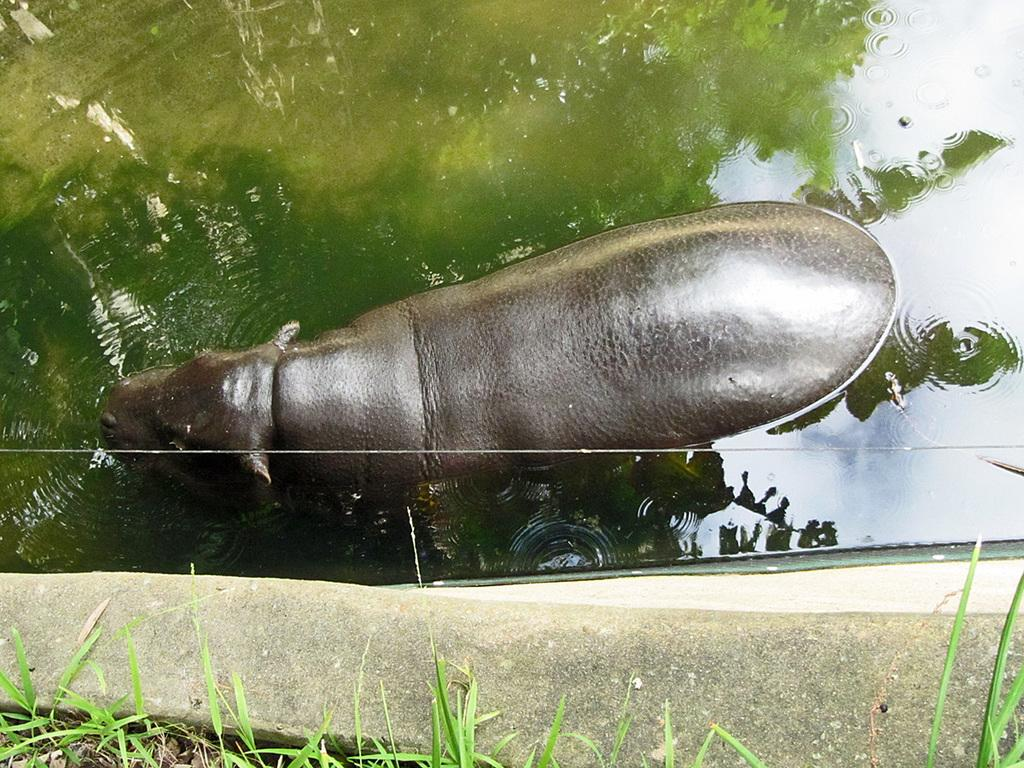What type of animal can be seen in the image? There is an animal in a pond in the image. What is located at the bottom of the image? There is a wall at the bottom of the image. What type of vegetation is visible in the image? There is grass visible in the image. How many dolls are sleeping on the snow in the image? There are no dolls or snow present in the image. 